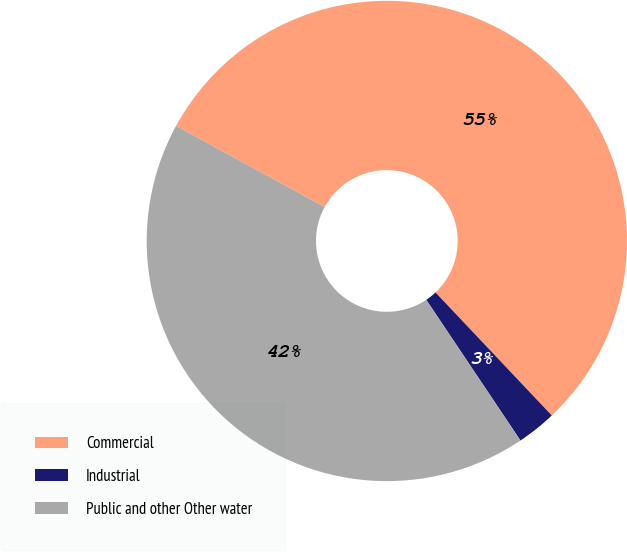Convert chart to OTSL. <chart><loc_0><loc_0><loc_500><loc_500><pie_chart><fcel>Commercial<fcel>Industrial<fcel>Public and other Other water<nl><fcel>55.0%<fcel>2.66%<fcel>42.34%<nl></chart> 